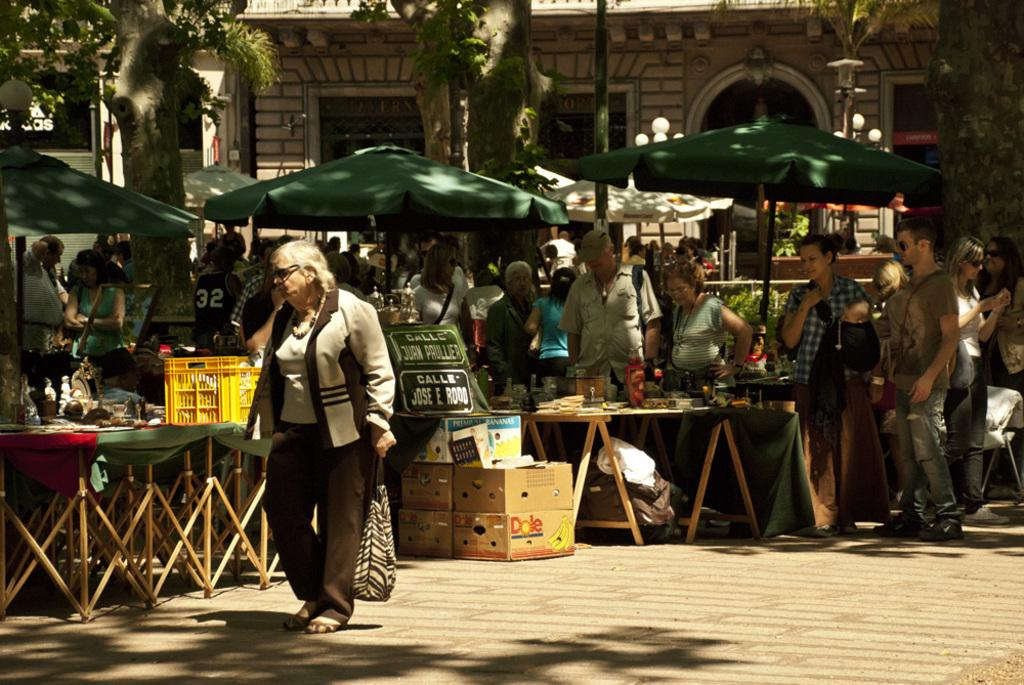<image>
Summarize the visual content of the image. Boxes with Dole fruit depicted on the side sit near stands on the street. 